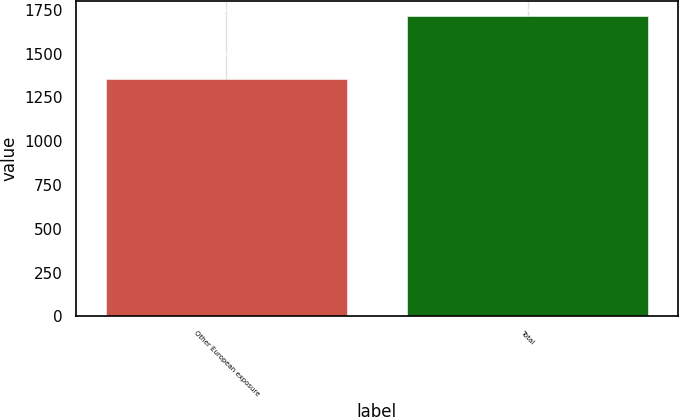Convert chart to OTSL. <chart><loc_0><loc_0><loc_500><loc_500><bar_chart><fcel>Other European exposure<fcel>Total<nl><fcel>1357<fcel>1715<nl></chart> 